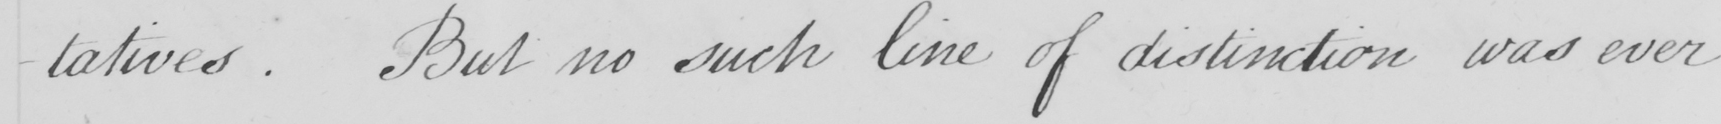Please provide the text content of this handwritten line. -tatives . But no such line of distinction was ever 